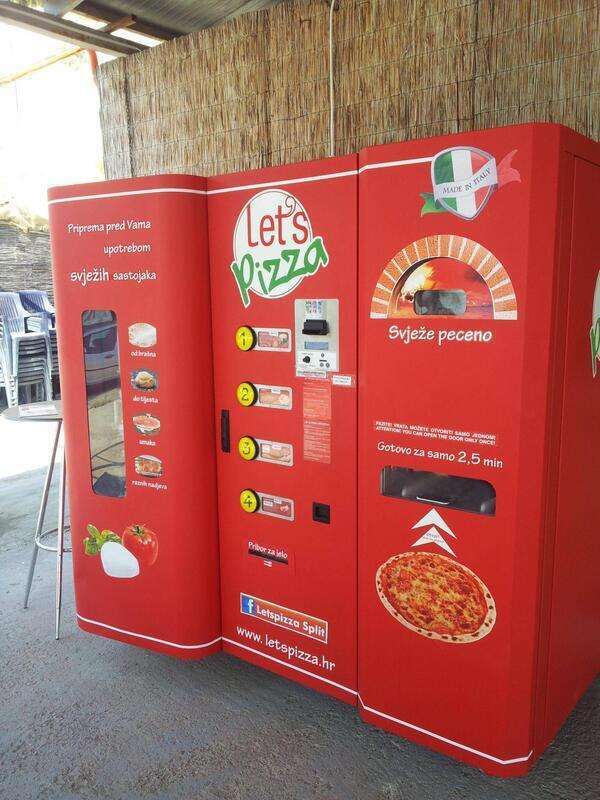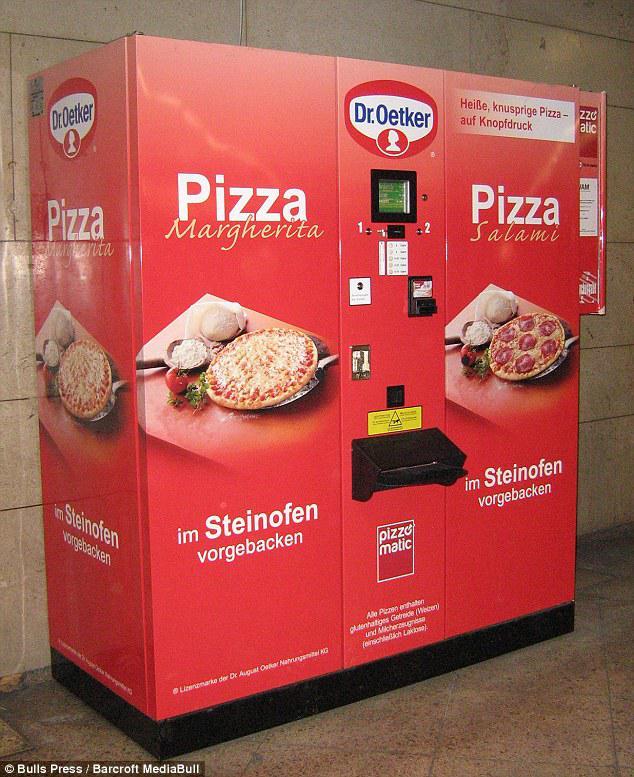The first image is the image on the left, the second image is the image on the right. Considering the images on both sides, is "Right and left images appear to show the same red pizza vending machine, with the same branding on the front." valid? Answer yes or no. No. 